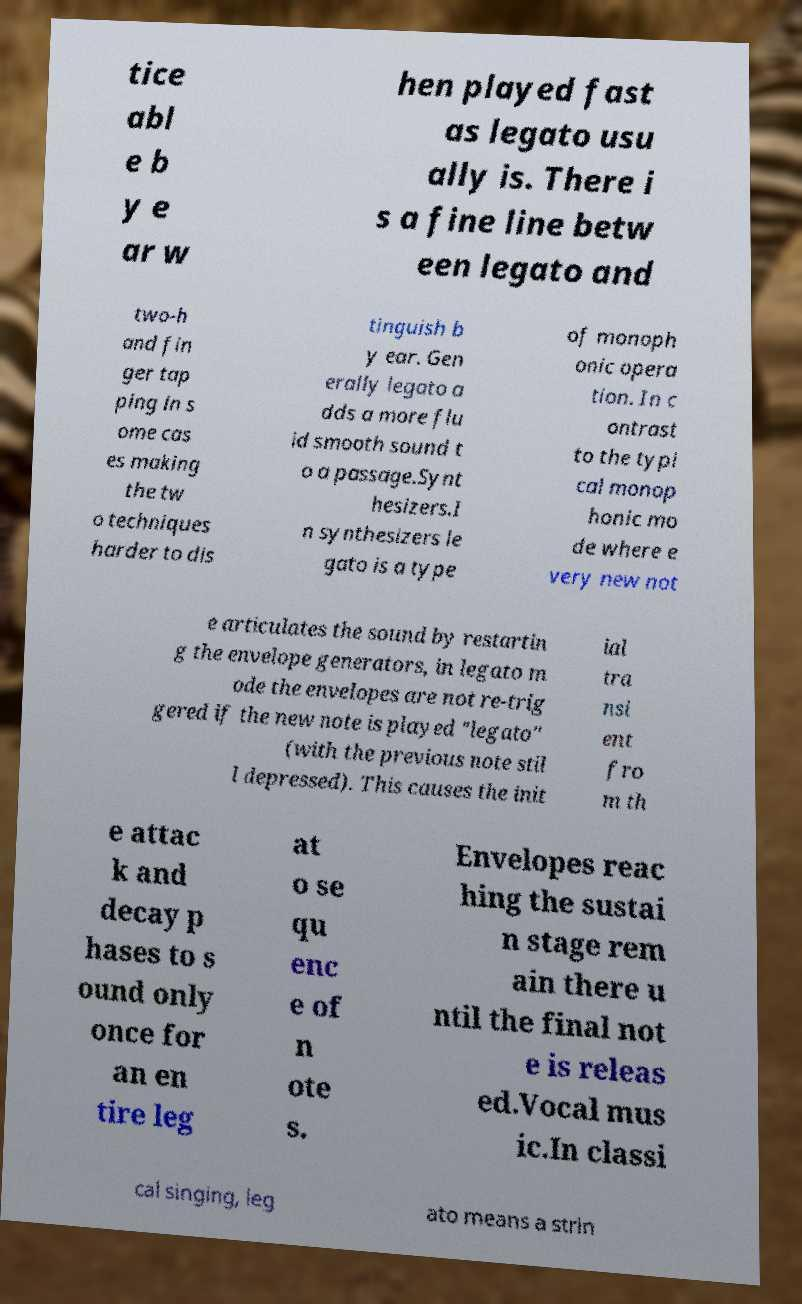What messages or text are displayed in this image? I need them in a readable, typed format. tice abl e b y e ar w hen played fast as legato usu ally is. There i s a fine line betw een legato and two-h and fin ger tap ping in s ome cas es making the tw o techniques harder to dis tinguish b y ear. Gen erally legato a dds a more flu id smooth sound t o a passage.Synt hesizers.I n synthesizers le gato is a type of monoph onic opera tion. In c ontrast to the typi cal monop honic mo de where e very new not e articulates the sound by restartin g the envelope generators, in legato m ode the envelopes are not re-trig gered if the new note is played "legato" (with the previous note stil l depressed). This causes the init ial tra nsi ent fro m th e attac k and decay p hases to s ound only once for an en tire leg at o se qu enc e of n ote s. Envelopes reac hing the sustai n stage rem ain there u ntil the final not e is releas ed.Vocal mus ic.In classi cal singing, leg ato means a strin 